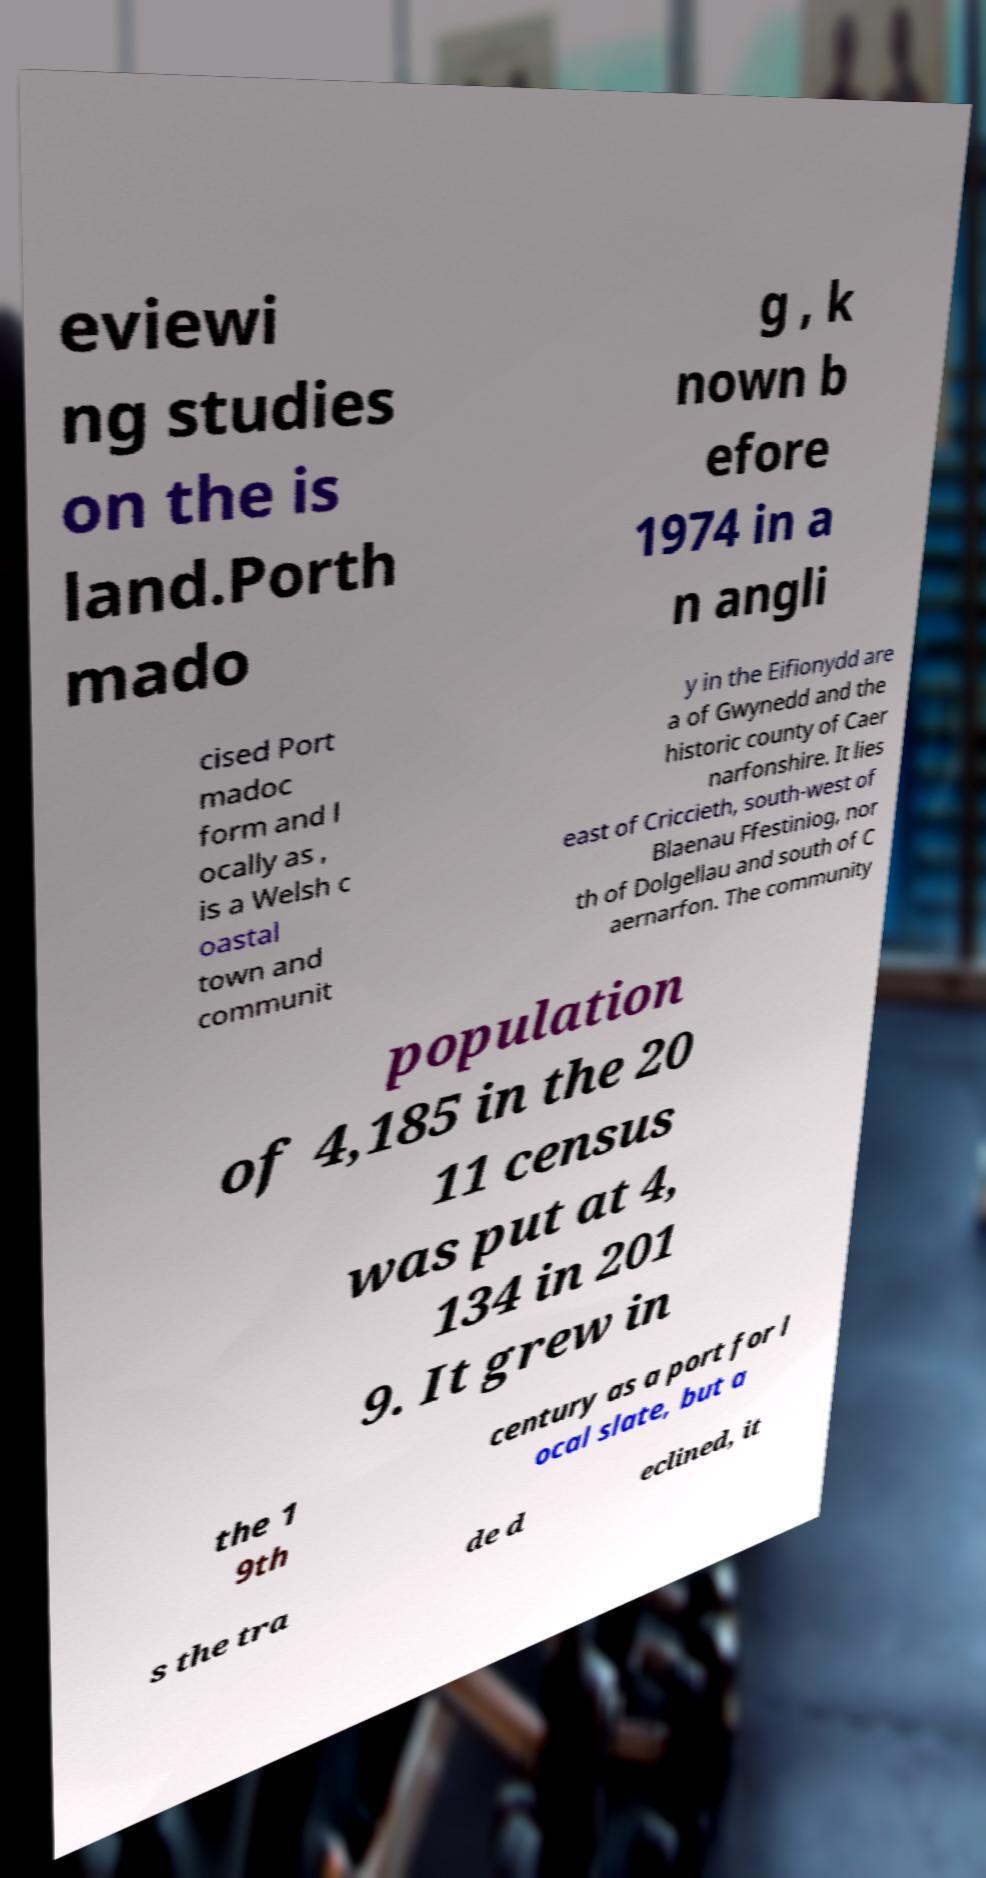I need the written content from this picture converted into text. Can you do that? eviewi ng studies on the is land.Porth mado g , k nown b efore 1974 in a n angli cised Port madoc form and l ocally as , is a Welsh c oastal town and communit y in the Eifionydd are a of Gwynedd and the historic county of Caer narfonshire. It lies east of Criccieth, south-west of Blaenau Ffestiniog, nor th of Dolgellau and south of C aernarfon. The community population of 4,185 in the 20 11 census was put at 4, 134 in 201 9. It grew in the 1 9th century as a port for l ocal slate, but a s the tra de d eclined, it 